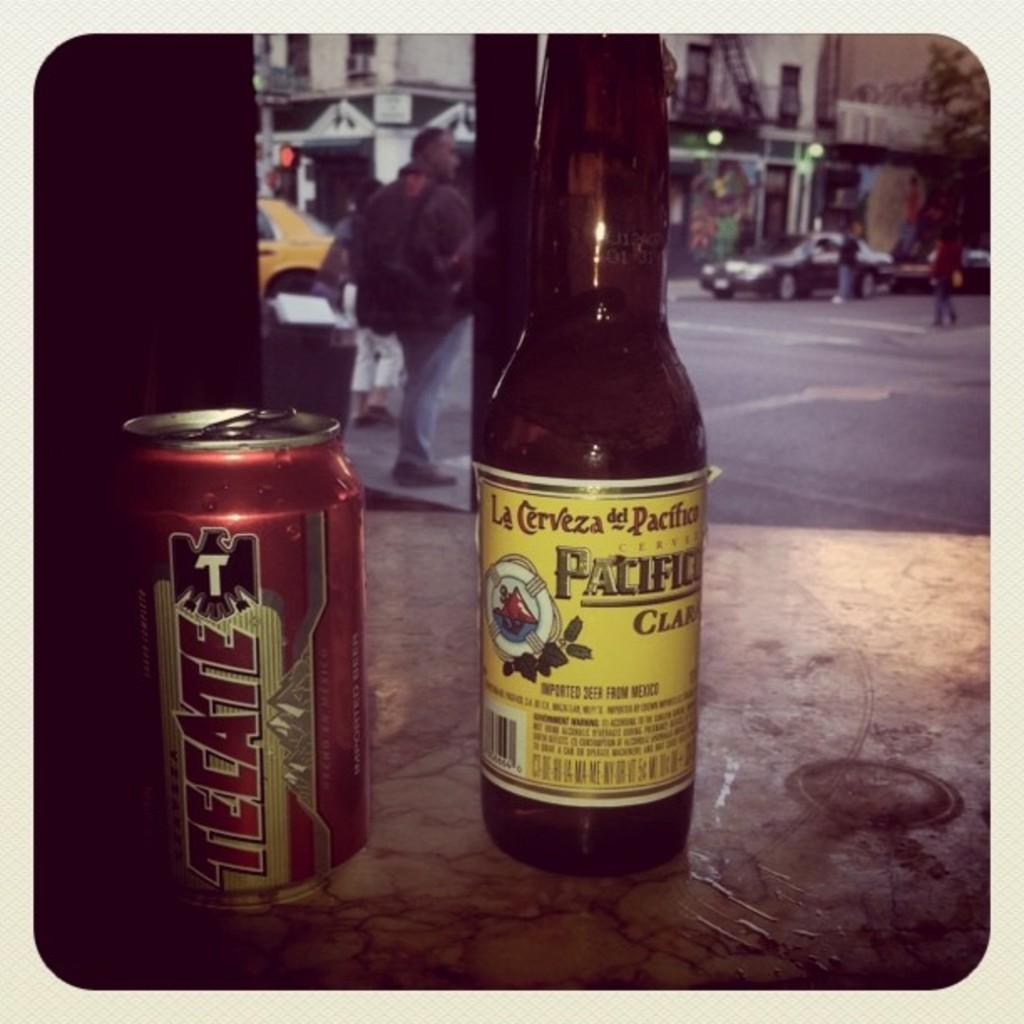Provide a one-sentence caption for the provided image. A can of beer called tecate sits next to a bottle of Pacifico. 